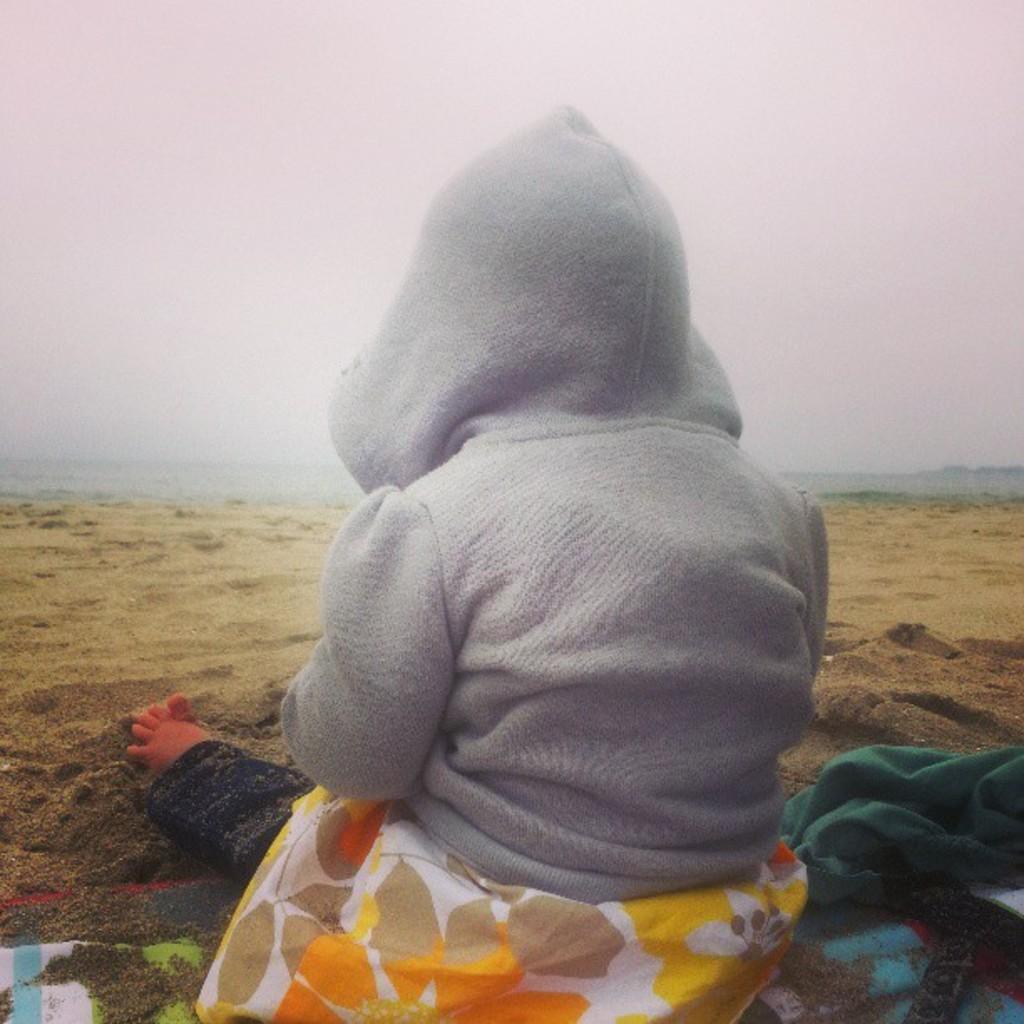Can you describe this image briefly? In the picture I can see a baby sitting on the sand and the baby is wearing a jacket. I can see a green colored cloth on the bottom right side of the picture. I can see the towel on the sand at the bottom of the picture. 